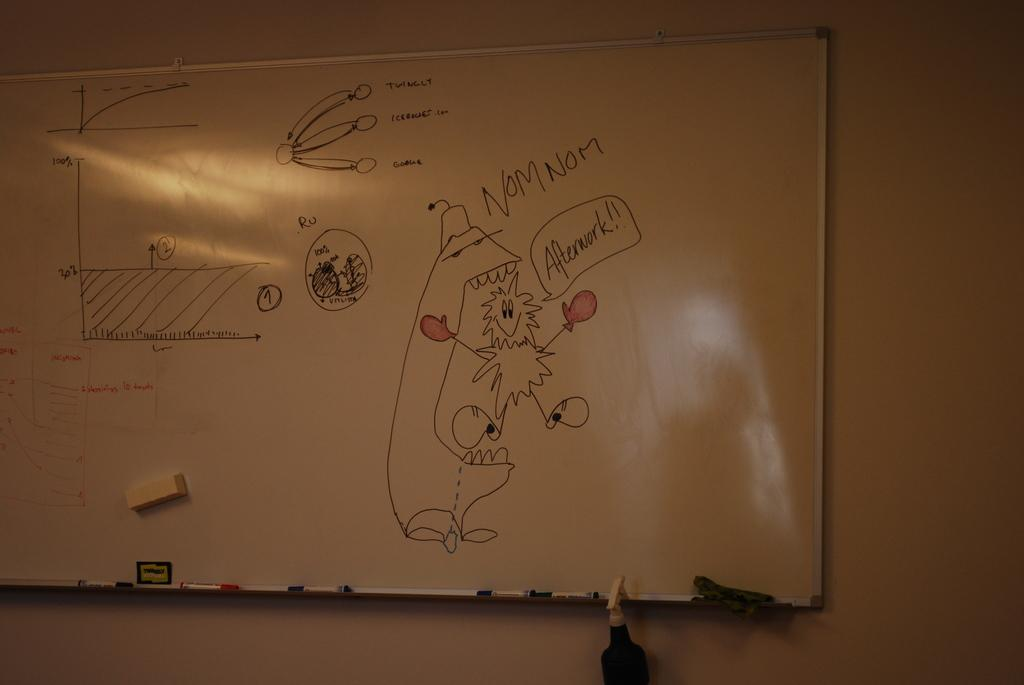<image>
Create a compact narrative representing the image presented. Someone has drawn a cartoon and written "nom nom" over it. 